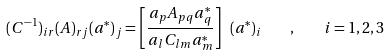<formula> <loc_0><loc_0><loc_500><loc_500>( { C } ^ { - 1 } ) _ { i r } ( { A } ) _ { r j } ( { a } ^ { * } ) _ { j } = \left [ \frac { { a } _ { p } { A } _ { p q } { a } ^ { * } _ { q } } { { a } _ { l } { C } _ { l m } { a } ^ { * } _ { m } } \right ] \ ( { a } ^ { * } ) _ { i } \quad , \quad i = 1 , 2 , 3</formula> 